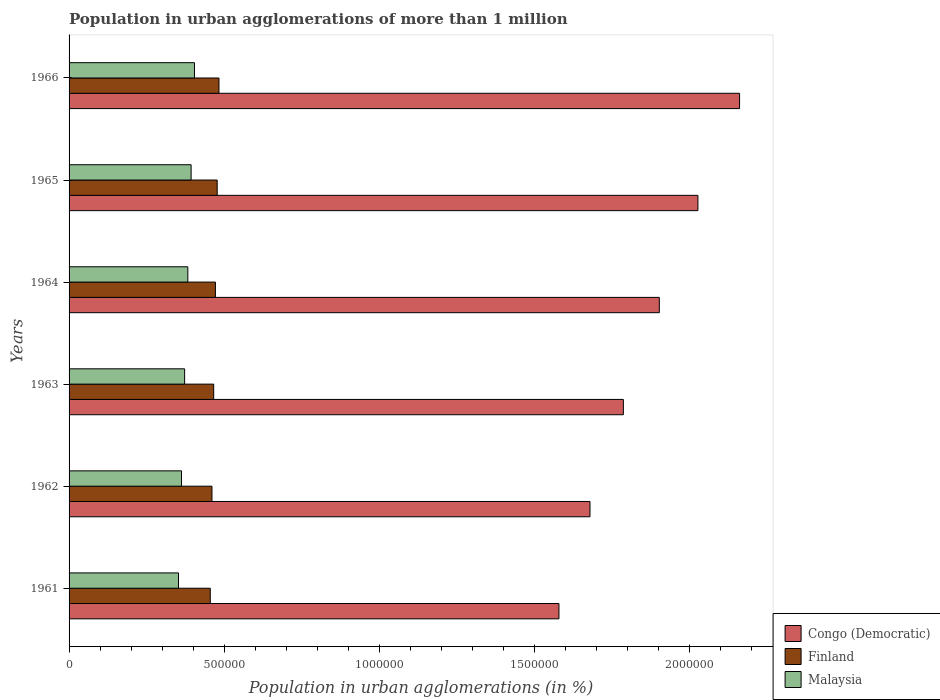Are the number of bars per tick equal to the number of legend labels?
Provide a short and direct response. Yes. Are the number of bars on each tick of the Y-axis equal?
Offer a terse response. Yes. How many bars are there on the 3rd tick from the top?
Your answer should be compact. 3. What is the label of the 2nd group of bars from the top?
Give a very brief answer. 1965. What is the population in urban agglomerations in Malaysia in 1961?
Keep it short and to the point. 3.53e+05. Across all years, what is the maximum population in urban agglomerations in Finland?
Provide a short and direct response. 4.84e+05. Across all years, what is the minimum population in urban agglomerations in Congo (Democratic)?
Offer a terse response. 1.58e+06. In which year was the population in urban agglomerations in Finland maximum?
Provide a short and direct response. 1966. What is the total population in urban agglomerations in Finland in the graph?
Offer a very short reply. 2.82e+06. What is the difference between the population in urban agglomerations in Malaysia in 1961 and that in 1963?
Offer a very short reply. -1.98e+04. What is the difference between the population in urban agglomerations in Finland in 1964 and the population in urban agglomerations in Congo (Democratic) in 1965?
Offer a terse response. -1.56e+06. What is the average population in urban agglomerations in Finland per year?
Provide a short and direct response. 4.69e+05. In the year 1963, what is the difference between the population in urban agglomerations in Finland and population in urban agglomerations in Congo (Democratic)?
Provide a succinct answer. -1.32e+06. In how many years, is the population in urban agglomerations in Finland greater than 1100000 %?
Ensure brevity in your answer.  0. What is the ratio of the population in urban agglomerations in Finland in 1964 to that in 1965?
Provide a succinct answer. 0.99. Is the population in urban agglomerations in Congo (Democratic) in 1962 less than that in 1963?
Ensure brevity in your answer.  Yes. What is the difference between the highest and the second highest population in urban agglomerations in Congo (Democratic)?
Give a very brief answer. 1.34e+05. What is the difference between the highest and the lowest population in urban agglomerations in Congo (Democratic)?
Offer a terse response. 5.83e+05. In how many years, is the population in urban agglomerations in Congo (Democratic) greater than the average population in urban agglomerations in Congo (Democratic) taken over all years?
Ensure brevity in your answer.  3. What does the 3rd bar from the top in 1961 represents?
Provide a short and direct response. Congo (Democratic). What does the 3rd bar from the bottom in 1961 represents?
Give a very brief answer. Malaysia. How many bars are there?
Your answer should be very brief. 18. How many years are there in the graph?
Offer a very short reply. 6. What is the difference between two consecutive major ticks on the X-axis?
Provide a succinct answer. 5.00e+05. How many legend labels are there?
Your answer should be very brief. 3. What is the title of the graph?
Give a very brief answer. Population in urban agglomerations of more than 1 million. What is the label or title of the X-axis?
Offer a very short reply. Population in urban agglomerations (in %). What is the Population in urban agglomerations (in %) of Congo (Democratic) in 1961?
Offer a very short reply. 1.58e+06. What is the Population in urban agglomerations (in %) of Finland in 1961?
Your answer should be compact. 4.55e+05. What is the Population in urban agglomerations (in %) in Malaysia in 1961?
Make the answer very short. 3.53e+05. What is the Population in urban agglomerations (in %) in Congo (Democratic) in 1962?
Offer a very short reply. 1.68e+06. What is the Population in urban agglomerations (in %) of Finland in 1962?
Your answer should be very brief. 4.61e+05. What is the Population in urban agglomerations (in %) of Malaysia in 1962?
Ensure brevity in your answer.  3.63e+05. What is the Population in urban agglomerations (in %) of Congo (Democratic) in 1963?
Offer a very short reply. 1.79e+06. What is the Population in urban agglomerations (in %) in Finland in 1963?
Your answer should be compact. 4.67e+05. What is the Population in urban agglomerations (in %) of Malaysia in 1963?
Your response must be concise. 3.73e+05. What is the Population in urban agglomerations (in %) in Congo (Democratic) in 1964?
Ensure brevity in your answer.  1.90e+06. What is the Population in urban agglomerations (in %) of Finland in 1964?
Your answer should be very brief. 4.72e+05. What is the Population in urban agglomerations (in %) of Malaysia in 1964?
Provide a succinct answer. 3.83e+05. What is the Population in urban agglomerations (in %) in Congo (Democratic) in 1965?
Offer a very short reply. 2.03e+06. What is the Population in urban agglomerations (in %) in Finland in 1965?
Your answer should be compact. 4.78e+05. What is the Population in urban agglomerations (in %) in Malaysia in 1965?
Make the answer very short. 3.94e+05. What is the Population in urban agglomerations (in %) of Congo (Democratic) in 1966?
Make the answer very short. 2.16e+06. What is the Population in urban agglomerations (in %) in Finland in 1966?
Provide a succinct answer. 4.84e+05. What is the Population in urban agglomerations (in %) of Malaysia in 1966?
Offer a very short reply. 4.05e+05. Across all years, what is the maximum Population in urban agglomerations (in %) in Congo (Democratic)?
Offer a terse response. 2.16e+06. Across all years, what is the maximum Population in urban agglomerations (in %) in Finland?
Make the answer very short. 4.84e+05. Across all years, what is the maximum Population in urban agglomerations (in %) of Malaysia?
Your answer should be compact. 4.05e+05. Across all years, what is the minimum Population in urban agglomerations (in %) in Congo (Democratic)?
Offer a very short reply. 1.58e+06. Across all years, what is the minimum Population in urban agglomerations (in %) of Finland?
Make the answer very short. 4.55e+05. Across all years, what is the minimum Population in urban agglomerations (in %) of Malaysia?
Offer a terse response. 3.53e+05. What is the total Population in urban agglomerations (in %) in Congo (Democratic) in the graph?
Your response must be concise. 1.11e+07. What is the total Population in urban agglomerations (in %) in Finland in the graph?
Your answer should be very brief. 2.82e+06. What is the total Population in urban agglomerations (in %) in Malaysia in the graph?
Make the answer very short. 2.27e+06. What is the difference between the Population in urban agglomerations (in %) in Congo (Democratic) in 1961 and that in 1962?
Your answer should be compact. -1.00e+05. What is the difference between the Population in urban agglomerations (in %) in Finland in 1961 and that in 1962?
Your answer should be very brief. -5485. What is the difference between the Population in urban agglomerations (in %) of Malaysia in 1961 and that in 1962?
Provide a succinct answer. -9758. What is the difference between the Population in urban agglomerations (in %) in Congo (Democratic) in 1961 and that in 1963?
Keep it short and to the point. -2.08e+05. What is the difference between the Population in urban agglomerations (in %) in Finland in 1961 and that in 1963?
Your response must be concise. -1.10e+04. What is the difference between the Population in urban agglomerations (in %) of Malaysia in 1961 and that in 1963?
Provide a succinct answer. -1.98e+04. What is the difference between the Population in urban agglomerations (in %) of Congo (Democratic) in 1961 and that in 1964?
Your response must be concise. -3.24e+05. What is the difference between the Population in urban agglomerations (in %) of Finland in 1961 and that in 1964?
Your answer should be very brief. -1.67e+04. What is the difference between the Population in urban agglomerations (in %) of Malaysia in 1961 and that in 1964?
Ensure brevity in your answer.  -3.01e+04. What is the difference between the Population in urban agglomerations (in %) in Congo (Democratic) in 1961 and that in 1965?
Keep it short and to the point. -4.48e+05. What is the difference between the Population in urban agglomerations (in %) of Finland in 1961 and that in 1965?
Provide a short and direct response. -2.23e+04. What is the difference between the Population in urban agglomerations (in %) of Malaysia in 1961 and that in 1965?
Ensure brevity in your answer.  -4.07e+04. What is the difference between the Population in urban agglomerations (in %) in Congo (Democratic) in 1961 and that in 1966?
Your answer should be compact. -5.83e+05. What is the difference between the Population in urban agglomerations (in %) of Finland in 1961 and that in 1966?
Offer a very short reply. -2.81e+04. What is the difference between the Population in urban agglomerations (in %) of Malaysia in 1961 and that in 1966?
Make the answer very short. -5.16e+04. What is the difference between the Population in urban agglomerations (in %) in Congo (Democratic) in 1962 and that in 1963?
Provide a succinct answer. -1.08e+05. What is the difference between the Population in urban agglomerations (in %) of Finland in 1962 and that in 1963?
Ensure brevity in your answer.  -5551. What is the difference between the Population in urban agglomerations (in %) of Malaysia in 1962 and that in 1963?
Offer a terse response. -1.00e+04. What is the difference between the Population in urban agglomerations (in %) in Congo (Democratic) in 1962 and that in 1964?
Keep it short and to the point. -2.24e+05. What is the difference between the Population in urban agglomerations (in %) of Finland in 1962 and that in 1964?
Provide a short and direct response. -1.12e+04. What is the difference between the Population in urban agglomerations (in %) in Malaysia in 1962 and that in 1964?
Provide a short and direct response. -2.03e+04. What is the difference between the Population in urban agglomerations (in %) in Congo (Democratic) in 1962 and that in 1965?
Offer a terse response. -3.48e+05. What is the difference between the Population in urban agglomerations (in %) in Finland in 1962 and that in 1965?
Offer a very short reply. -1.69e+04. What is the difference between the Population in urban agglomerations (in %) of Malaysia in 1962 and that in 1965?
Give a very brief answer. -3.09e+04. What is the difference between the Population in urban agglomerations (in %) in Congo (Democratic) in 1962 and that in 1966?
Make the answer very short. -4.83e+05. What is the difference between the Population in urban agglomerations (in %) of Finland in 1962 and that in 1966?
Keep it short and to the point. -2.26e+04. What is the difference between the Population in urban agglomerations (in %) of Malaysia in 1962 and that in 1966?
Your answer should be compact. -4.18e+04. What is the difference between the Population in urban agglomerations (in %) in Congo (Democratic) in 1963 and that in 1964?
Offer a terse response. -1.16e+05. What is the difference between the Population in urban agglomerations (in %) of Finland in 1963 and that in 1964?
Make the answer very short. -5625. What is the difference between the Population in urban agglomerations (in %) of Malaysia in 1963 and that in 1964?
Offer a very short reply. -1.03e+04. What is the difference between the Population in urban agglomerations (in %) of Congo (Democratic) in 1963 and that in 1965?
Make the answer very short. -2.41e+05. What is the difference between the Population in urban agglomerations (in %) of Finland in 1963 and that in 1965?
Keep it short and to the point. -1.13e+04. What is the difference between the Population in urban agglomerations (in %) in Malaysia in 1963 and that in 1965?
Your answer should be very brief. -2.09e+04. What is the difference between the Population in urban agglomerations (in %) of Congo (Democratic) in 1963 and that in 1966?
Provide a succinct answer. -3.75e+05. What is the difference between the Population in urban agglomerations (in %) of Finland in 1963 and that in 1966?
Offer a terse response. -1.71e+04. What is the difference between the Population in urban agglomerations (in %) of Malaysia in 1963 and that in 1966?
Your response must be concise. -3.18e+04. What is the difference between the Population in urban agglomerations (in %) of Congo (Democratic) in 1964 and that in 1965?
Your answer should be compact. -1.25e+05. What is the difference between the Population in urban agglomerations (in %) in Finland in 1964 and that in 1965?
Your answer should be compact. -5678. What is the difference between the Population in urban agglomerations (in %) in Malaysia in 1964 and that in 1965?
Offer a terse response. -1.06e+04. What is the difference between the Population in urban agglomerations (in %) in Congo (Democratic) in 1964 and that in 1966?
Provide a succinct answer. -2.59e+05. What is the difference between the Population in urban agglomerations (in %) of Finland in 1964 and that in 1966?
Offer a very short reply. -1.14e+04. What is the difference between the Population in urban agglomerations (in %) of Malaysia in 1964 and that in 1966?
Provide a short and direct response. -2.15e+04. What is the difference between the Population in urban agglomerations (in %) of Congo (Democratic) in 1965 and that in 1966?
Provide a succinct answer. -1.34e+05. What is the difference between the Population in urban agglomerations (in %) in Finland in 1965 and that in 1966?
Provide a short and direct response. -5754. What is the difference between the Population in urban agglomerations (in %) of Malaysia in 1965 and that in 1966?
Keep it short and to the point. -1.09e+04. What is the difference between the Population in urban agglomerations (in %) of Congo (Democratic) in 1961 and the Population in urban agglomerations (in %) of Finland in 1962?
Provide a succinct answer. 1.12e+06. What is the difference between the Population in urban agglomerations (in %) in Congo (Democratic) in 1961 and the Population in urban agglomerations (in %) in Malaysia in 1962?
Your answer should be very brief. 1.22e+06. What is the difference between the Population in urban agglomerations (in %) in Finland in 1961 and the Population in urban agglomerations (in %) in Malaysia in 1962?
Provide a succinct answer. 9.27e+04. What is the difference between the Population in urban agglomerations (in %) of Congo (Democratic) in 1961 and the Population in urban agglomerations (in %) of Finland in 1963?
Offer a very short reply. 1.11e+06. What is the difference between the Population in urban agglomerations (in %) of Congo (Democratic) in 1961 and the Population in urban agglomerations (in %) of Malaysia in 1963?
Your answer should be very brief. 1.21e+06. What is the difference between the Population in urban agglomerations (in %) in Finland in 1961 and the Population in urban agglomerations (in %) in Malaysia in 1963?
Ensure brevity in your answer.  8.27e+04. What is the difference between the Population in urban agglomerations (in %) in Congo (Democratic) in 1961 and the Population in urban agglomerations (in %) in Finland in 1964?
Ensure brevity in your answer.  1.11e+06. What is the difference between the Population in urban agglomerations (in %) of Congo (Democratic) in 1961 and the Population in urban agglomerations (in %) of Malaysia in 1964?
Your response must be concise. 1.20e+06. What is the difference between the Population in urban agglomerations (in %) in Finland in 1961 and the Population in urban agglomerations (in %) in Malaysia in 1964?
Your answer should be very brief. 7.24e+04. What is the difference between the Population in urban agglomerations (in %) in Congo (Democratic) in 1961 and the Population in urban agglomerations (in %) in Finland in 1965?
Provide a succinct answer. 1.10e+06. What is the difference between the Population in urban agglomerations (in %) of Congo (Democratic) in 1961 and the Population in urban agglomerations (in %) of Malaysia in 1965?
Ensure brevity in your answer.  1.19e+06. What is the difference between the Population in urban agglomerations (in %) in Finland in 1961 and the Population in urban agglomerations (in %) in Malaysia in 1965?
Ensure brevity in your answer.  6.18e+04. What is the difference between the Population in urban agglomerations (in %) in Congo (Democratic) in 1961 and the Population in urban agglomerations (in %) in Finland in 1966?
Offer a very short reply. 1.10e+06. What is the difference between the Population in urban agglomerations (in %) in Congo (Democratic) in 1961 and the Population in urban agglomerations (in %) in Malaysia in 1966?
Your answer should be very brief. 1.18e+06. What is the difference between the Population in urban agglomerations (in %) of Finland in 1961 and the Population in urban agglomerations (in %) of Malaysia in 1966?
Provide a succinct answer. 5.09e+04. What is the difference between the Population in urban agglomerations (in %) in Congo (Democratic) in 1962 and the Population in urban agglomerations (in %) in Finland in 1963?
Provide a short and direct response. 1.21e+06. What is the difference between the Population in urban agglomerations (in %) of Congo (Democratic) in 1962 and the Population in urban agglomerations (in %) of Malaysia in 1963?
Give a very brief answer. 1.31e+06. What is the difference between the Population in urban agglomerations (in %) of Finland in 1962 and the Population in urban agglomerations (in %) of Malaysia in 1963?
Ensure brevity in your answer.  8.82e+04. What is the difference between the Population in urban agglomerations (in %) in Congo (Democratic) in 1962 and the Population in urban agglomerations (in %) in Finland in 1964?
Offer a very short reply. 1.21e+06. What is the difference between the Population in urban agglomerations (in %) in Congo (Democratic) in 1962 and the Population in urban agglomerations (in %) in Malaysia in 1964?
Provide a short and direct response. 1.30e+06. What is the difference between the Population in urban agglomerations (in %) in Finland in 1962 and the Population in urban agglomerations (in %) in Malaysia in 1964?
Your response must be concise. 7.79e+04. What is the difference between the Population in urban agglomerations (in %) in Congo (Democratic) in 1962 and the Population in urban agglomerations (in %) in Finland in 1965?
Provide a succinct answer. 1.20e+06. What is the difference between the Population in urban agglomerations (in %) in Congo (Democratic) in 1962 and the Population in urban agglomerations (in %) in Malaysia in 1965?
Your answer should be very brief. 1.29e+06. What is the difference between the Population in urban agglomerations (in %) of Finland in 1962 and the Population in urban agglomerations (in %) of Malaysia in 1965?
Offer a terse response. 6.73e+04. What is the difference between the Population in urban agglomerations (in %) in Congo (Democratic) in 1962 and the Population in urban agglomerations (in %) in Finland in 1966?
Ensure brevity in your answer.  1.20e+06. What is the difference between the Population in urban agglomerations (in %) of Congo (Democratic) in 1962 and the Population in urban agglomerations (in %) of Malaysia in 1966?
Offer a very short reply. 1.28e+06. What is the difference between the Population in urban agglomerations (in %) of Finland in 1962 and the Population in urban agglomerations (in %) of Malaysia in 1966?
Provide a succinct answer. 5.64e+04. What is the difference between the Population in urban agglomerations (in %) of Congo (Democratic) in 1963 and the Population in urban agglomerations (in %) of Finland in 1964?
Ensure brevity in your answer.  1.32e+06. What is the difference between the Population in urban agglomerations (in %) in Congo (Democratic) in 1963 and the Population in urban agglomerations (in %) in Malaysia in 1964?
Make the answer very short. 1.40e+06. What is the difference between the Population in urban agglomerations (in %) in Finland in 1963 and the Population in urban agglomerations (in %) in Malaysia in 1964?
Your answer should be very brief. 8.34e+04. What is the difference between the Population in urban agglomerations (in %) of Congo (Democratic) in 1963 and the Population in urban agglomerations (in %) of Finland in 1965?
Provide a succinct answer. 1.31e+06. What is the difference between the Population in urban agglomerations (in %) in Congo (Democratic) in 1963 and the Population in urban agglomerations (in %) in Malaysia in 1965?
Offer a terse response. 1.39e+06. What is the difference between the Population in urban agglomerations (in %) in Finland in 1963 and the Population in urban agglomerations (in %) in Malaysia in 1965?
Offer a terse response. 7.28e+04. What is the difference between the Population in urban agglomerations (in %) of Congo (Democratic) in 1963 and the Population in urban agglomerations (in %) of Finland in 1966?
Provide a short and direct response. 1.30e+06. What is the difference between the Population in urban agglomerations (in %) in Congo (Democratic) in 1963 and the Population in urban agglomerations (in %) in Malaysia in 1966?
Your answer should be very brief. 1.38e+06. What is the difference between the Population in urban agglomerations (in %) in Finland in 1963 and the Population in urban agglomerations (in %) in Malaysia in 1966?
Your answer should be very brief. 6.19e+04. What is the difference between the Population in urban agglomerations (in %) of Congo (Democratic) in 1964 and the Population in urban agglomerations (in %) of Finland in 1965?
Your answer should be very brief. 1.43e+06. What is the difference between the Population in urban agglomerations (in %) in Congo (Democratic) in 1964 and the Population in urban agglomerations (in %) in Malaysia in 1965?
Ensure brevity in your answer.  1.51e+06. What is the difference between the Population in urban agglomerations (in %) in Finland in 1964 and the Population in urban agglomerations (in %) in Malaysia in 1965?
Provide a succinct answer. 7.85e+04. What is the difference between the Population in urban agglomerations (in %) of Congo (Democratic) in 1964 and the Population in urban agglomerations (in %) of Finland in 1966?
Ensure brevity in your answer.  1.42e+06. What is the difference between the Population in urban agglomerations (in %) in Congo (Democratic) in 1964 and the Population in urban agglomerations (in %) in Malaysia in 1966?
Provide a short and direct response. 1.50e+06. What is the difference between the Population in urban agglomerations (in %) of Finland in 1964 and the Population in urban agglomerations (in %) of Malaysia in 1966?
Your response must be concise. 6.76e+04. What is the difference between the Population in urban agglomerations (in %) in Congo (Democratic) in 1965 and the Population in urban agglomerations (in %) in Finland in 1966?
Provide a succinct answer. 1.55e+06. What is the difference between the Population in urban agglomerations (in %) of Congo (Democratic) in 1965 and the Population in urban agglomerations (in %) of Malaysia in 1966?
Provide a short and direct response. 1.62e+06. What is the difference between the Population in urban agglomerations (in %) in Finland in 1965 and the Population in urban agglomerations (in %) in Malaysia in 1966?
Give a very brief answer. 7.33e+04. What is the average Population in urban agglomerations (in %) of Congo (Democratic) per year?
Your response must be concise. 1.86e+06. What is the average Population in urban agglomerations (in %) of Finland per year?
Provide a short and direct response. 4.69e+05. What is the average Population in urban agglomerations (in %) of Malaysia per year?
Your answer should be very brief. 3.78e+05. In the year 1961, what is the difference between the Population in urban agglomerations (in %) of Congo (Democratic) and Population in urban agglomerations (in %) of Finland?
Your answer should be very brief. 1.12e+06. In the year 1961, what is the difference between the Population in urban agglomerations (in %) of Congo (Democratic) and Population in urban agglomerations (in %) of Malaysia?
Provide a short and direct response. 1.23e+06. In the year 1961, what is the difference between the Population in urban agglomerations (in %) of Finland and Population in urban agglomerations (in %) of Malaysia?
Your answer should be very brief. 1.02e+05. In the year 1962, what is the difference between the Population in urban agglomerations (in %) in Congo (Democratic) and Population in urban agglomerations (in %) in Finland?
Provide a succinct answer. 1.22e+06. In the year 1962, what is the difference between the Population in urban agglomerations (in %) in Congo (Democratic) and Population in urban agglomerations (in %) in Malaysia?
Your answer should be compact. 1.32e+06. In the year 1962, what is the difference between the Population in urban agglomerations (in %) of Finland and Population in urban agglomerations (in %) of Malaysia?
Offer a terse response. 9.82e+04. In the year 1963, what is the difference between the Population in urban agglomerations (in %) of Congo (Democratic) and Population in urban agglomerations (in %) of Finland?
Ensure brevity in your answer.  1.32e+06. In the year 1963, what is the difference between the Population in urban agglomerations (in %) of Congo (Democratic) and Population in urban agglomerations (in %) of Malaysia?
Ensure brevity in your answer.  1.42e+06. In the year 1963, what is the difference between the Population in urban agglomerations (in %) of Finland and Population in urban agglomerations (in %) of Malaysia?
Provide a succinct answer. 9.37e+04. In the year 1964, what is the difference between the Population in urban agglomerations (in %) in Congo (Democratic) and Population in urban agglomerations (in %) in Finland?
Provide a succinct answer. 1.43e+06. In the year 1964, what is the difference between the Population in urban agglomerations (in %) of Congo (Democratic) and Population in urban agglomerations (in %) of Malaysia?
Make the answer very short. 1.52e+06. In the year 1964, what is the difference between the Population in urban agglomerations (in %) in Finland and Population in urban agglomerations (in %) in Malaysia?
Provide a short and direct response. 8.90e+04. In the year 1965, what is the difference between the Population in urban agglomerations (in %) in Congo (Democratic) and Population in urban agglomerations (in %) in Finland?
Ensure brevity in your answer.  1.55e+06. In the year 1965, what is the difference between the Population in urban agglomerations (in %) in Congo (Democratic) and Population in urban agglomerations (in %) in Malaysia?
Offer a terse response. 1.63e+06. In the year 1965, what is the difference between the Population in urban agglomerations (in %) of Finland and Population in urban agglomerations (in %) of Malaysia?
Offer a terse response. 8.41e+04. In the year 1966, what is the difference between the Population in urban agglomerations (in %) of Congo (Democratic) and Population in urban agglomerations (in %) of Finland?
Offer a very short reply. 1.68e+06. In the year 1966, what is the difference between the Population in urban agglomerations (in %) in Congo (Democratic) and Population in urban agglomerations (in %) in Malaysia?
Your response must be concise. 1.76e+06. In the year 1966, what is the difference between the Population in urban agglomerations (in %) of Finland and Population in urban agglomerations (in %) of Malaysia?
Provide a short and direct response. 7.90e+04. What is the ratio of the Population in urban agglomerations (in %) in Congo (Democratic) in 1961 to that in 1962?
Give a very brief answer. 0.94. What is the ratio of the Population in urban agglomerations (in %) in Malaysia in 1961 to that in 1962?
Offer a terse response. 0.97. What is the ratio of the Population in urban agglomerations (in %) in Congo (Democratic) in 1961 to that in 1963?
Ensure brevity in your answer.  0.88. What is the ratio of the Population in urban agglomerations (in %) in Finland in 1961 to that in 1963?
Provide a short and direct response. 0.98. What is the ratio of the Population in urban agglomerations (in %) in Malaysia in 1961 to that in 1963?
Provide a short and direct response. 0.95. What is the ratio of the Population in urban agglomerations (in %) in Congo (Democratic) in 1961 to that in 1964?
Provide a succinct answer. 0.83. What is the ratio of the Population in urban agglomerations (in %) in Finland in 1961 to that in 1964?
Your answer should be very brief. 0.96. What is the ratio of the Population in urban agglomerations (in %) of Malaysia in 1961 to that in 1964?
Your response must be concise. 0.92. What is the ratio of the Population in urban agglomerations (in %) in Congo (Democratic) in 1961 to that in 1965?
Provide a succinct answer. 0.78. What is the ratio of the Population in urban agglomerations (in %) of Finland in 1961 to that in 1965?
Provide a short and direct response. 0.95. What is the ratio of the Population in urban agglomerations (in %) of Malaysia in 1961 to that in 1965?
Make the answer very short. 0.9. What is the ratio of the Population in urban agglomerations (in %) of Congo (Democratic) in 1961 to that in 1966?
Provide a short and direct response. 0.73. What is the ratio of the Population in urban agglomerations (in %) in Finland in 1961 to that in 1966?
Give a very brief answer. 0.94. What is the ratio of the Population in urban agglomerations (in %) in Malaysia in 1961 to that in 1966?
Offer a very short reply. 0.87. What is the ratio of the Population in urban agglomerations (in %) in Congo (Democratic) in 1962 to that in 1963?
Provide a short and direct response. 0.94. What is the ratio of the Population in urban agglomerations (in %) in Malaysia in 1962 to that in 1963?
Provide a short and direct response. 0.97. What is the ratio of the Population in urban agglomerations (in %) of Congo (Democratic) in 1962 to that in 1964?
Make the answer very short. 0.88. What is the ratio of the Population in urban agglomerations (in %) of Finland in 1962 to that in 1964?
Make the answer very short. 0.98. What is the ratio of the Population in urban agglomerations (in %) in Malaysia in 1962 to that in 1964?
Offer a terse response. 0.95. What is the ratio of the Population in urban agglomerations (in %) in Congo (Democratic) in 1962 to that in 1965?
Keep it short and to the point. 0.83. What is the ratio of the Population in urban agglomerations (in %) in Finland in 1962 to that in 1965?
Make the answer very short. 0.96. What is the ratio of the Population in urban agglomerations (in %) in Malaysia in 1962 to that in 1965?
Provide a short and direct response. 0.92. What is the ratio of the Population in urban agglomerations (in %) of Congo (Democratic) in 1962 to that in 1966?
Your answer should be compact. 0.78. What is the ratio of the Population in urban agglomerations (in %) in Finland in 1962 to that in 1966?
Provide a succinct answer. 0.95. What is the ratio of the Population in urban agglomerations (in %) of Malaysia in 1962 to that in 1966?
Your answer should be very brief. 0.9. What is the ratio of the Population in urban agglomerations (in %) of Congo (Democratic) in 1963 to that in 1964?
Give a very brief answer. 0.94. What is the ratio of the Population in urban agglomerations (in %) of Malaysia in 1963 to that in 1964?
Your answer should be very brief. 0.97. What is the ratio of the Population in urban agglomerations (in %) in Congo (Democratic) in 1963 to that in 1965?
Ensure brevity in your answer.  0.88. What is the ratio of the Population in urban agglomerations (in %) of Finland in 1963 to that in 1965?
Your answer should be compact. 0.98. What is the ratio of the Population in urban agglomerations (in %) of Malaysia in 1963 to that in 1965?
Offer a very short reply. 0.95. What is the ratio of the Population in urban agglomerations (in %) of Congo (Democratic) in 1963 to that in 1966?
Give a very brief answer. 0.83. What is the ratio of the Population in urban agglomerations (in %) in Finland in 1963 to that in 1966?
Make the answer very short. 0.96. What is the ratio of the Population in urban agglomerations (in %) in Malaysia in 1963 to that in 1966?
Give a very brief answer. 0.92. What is the ratio of the Population in urban agglomerations (in %) in Congo (Democratic) in 1964 to that in 1965?
Offer a very short reply. 0.94. What is the ratio of the Population in urban agglomerations (in %) in Malaysia in 1964 to that in 1965?
Make the answer very short. 0.97. What is the ratio of the Population in urban agglomerations (in %) of Congo (Democratic) in 1964 to that in 1966?
Ensure brevity in your answer.  0.88. What is the ratio of the Population in urban agglomerations (in %) in Finland in 1964 to that in 1966?
Offer a very short reply. 0.98. What is the ratio of the Population in urban agglomerations (in %) in Malaysia in 1964 to that in 1966?
Ensure brevity in your answer.  0.95. What is the ratio of the Population in urban agglomerations (in %) of Congo (Democratic) in 1965 to that in 1966?
Make the answer very short. 0.94. What is the ratio of the Population in urban agglomerations (in %) of Malaysia in 1965 to that in 1966?
Provide a short and direct response. 0.97. What is the difference between the highest and the second highest Population in urban agglomerations (in %) in Congo (Democratic)?
Provide a short and direct response. 1.34e+05. What is the difference between the highest and the second highest Population in urban agglomerations (in %) of Finland?
Provide a short and direct response. 5754. What is the difference between the highest and the second highest Population in urban agglomerations (in %) of Malaysia?
Make the answer very short. 1.09e+04. What is the difference between the highest and the lowest Population in urban agglomerations (in %) of Congo (Democratic)?
Offer a terse response. 5.83e+05. What is the difference between the highest and the lowest Population in urban agglomerations (in %) of Finland?
Your answer should be compact. 2.81e+04. What is the difference between the highest and the lowest Population in urban agglomerations (in %) in Malaysia?
Keep it short and to the point. 5.16e+04. 